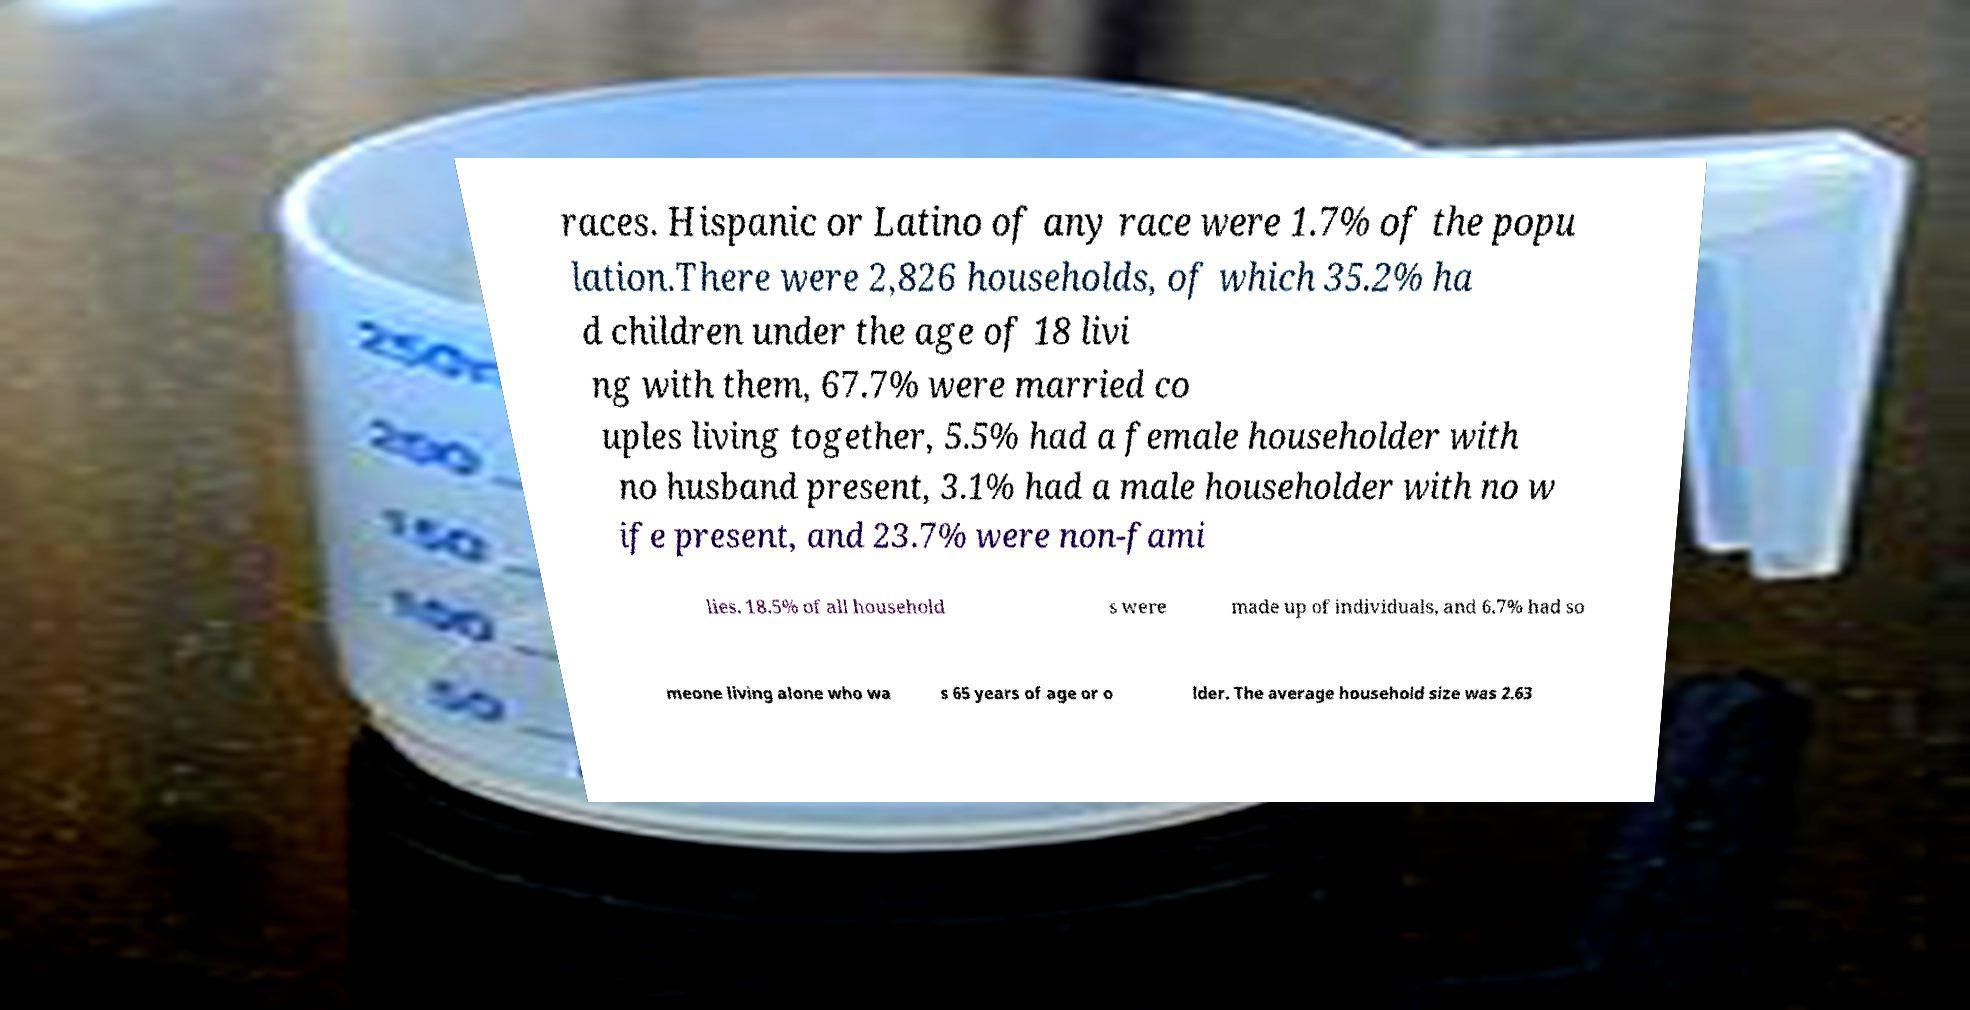There's text embedded in this image that I need extracted. Can you transcribe it verbatim? races. Hispanic or Latino of any race were 1.7% of the popu lation.There were 2,826 households, of which 35.2% ha d children under the age of 18 livi ng with them, 67.7% were married co uples living together, 5.5% had a female householder with no husband present, 3.1% had a male householder with no w ife present, and 23.7% were non-fami lies. 18.5% of all household s were made up of individuals, and 6.7% had so meone living alone who wa s 65 years of age or o lder. The average household size was 2.63 